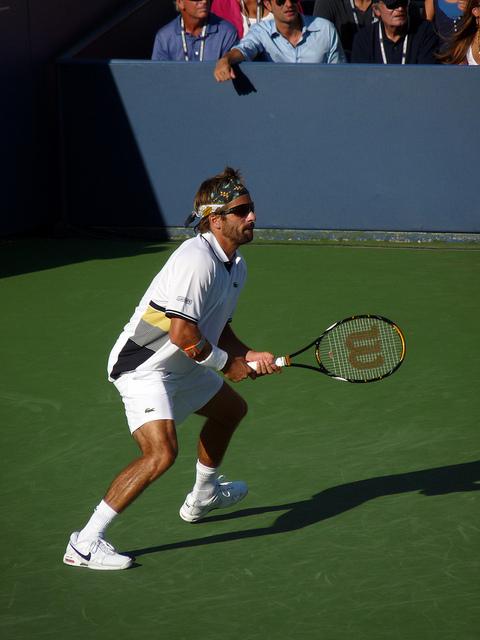What is on the man's head?
Give a very brief answer. Bandana. What color are the mans socks?
Be succinct. White. Who is winning this match?
Quick response, please. Man. Is this tennis court red clay or red concrete?
Write a very short answer. Green. What color is his hair?
Concise answer only. Brown. Is he preparing for a backhand or a forehand?
Answer briefly. Forehand. What sport is shown?
Quick response, please. Tennis. Has he hit the ball yet?
Be succinct. No. Is his left hand clenched?
Concise answer only. Yes. Is he wearing a Lacoste outfit?
Write a very short answer. Yes. What sport is this?
Write a very short answer. Tennis. 